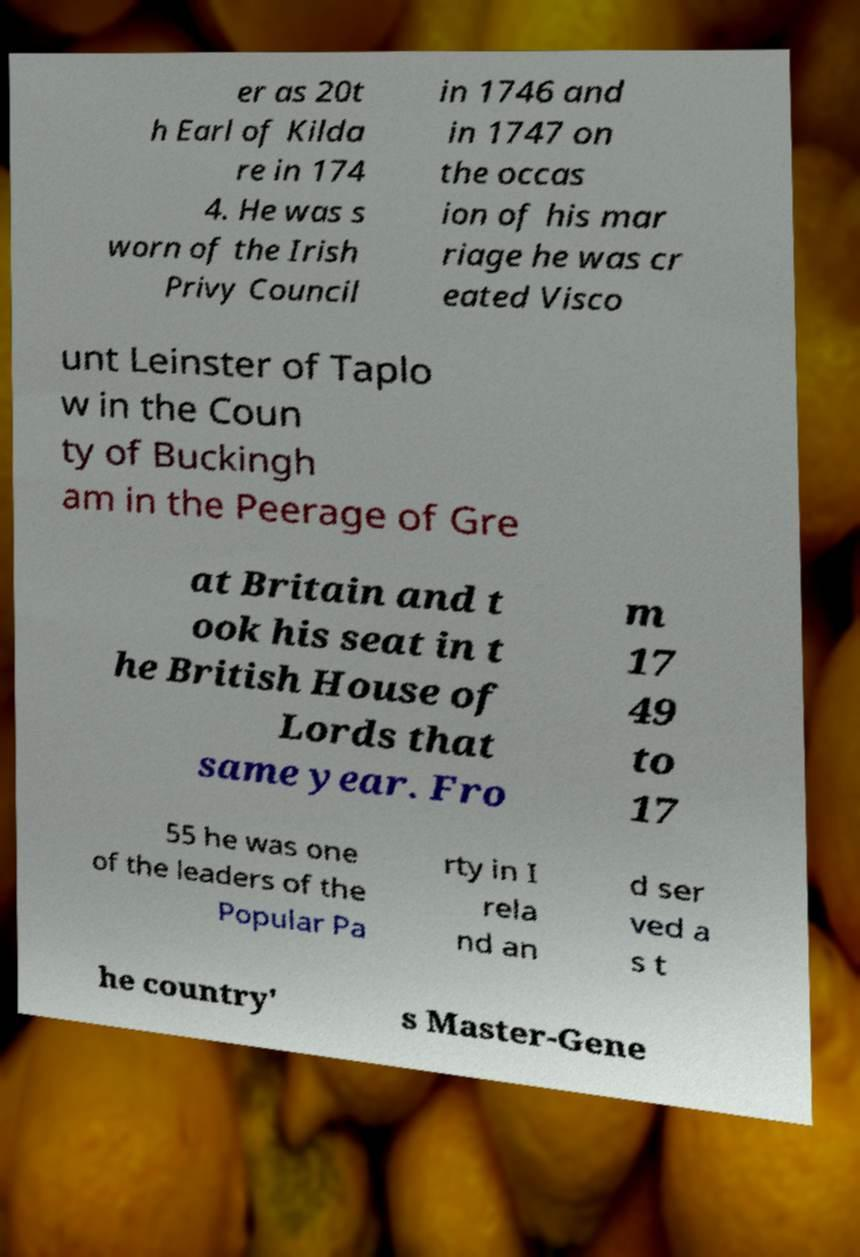Please read and relay the text visible in this image. What does it say? er as 20t h Earl of Kilda re in 174 4. He was s worn of the Irish Privy Council in 1746 and in 1747 on the occas ion of his mar riage he was cr eated Visco unt Leinster of Taplo w in the Coun ty of Buckingh am in the Peerage of Gre at Britain and t ook his seat in t he British House of Lords that same year. Fro m 17 49 to 17 55 he was one of the leaders of the Popular Pa rty in I rela nd an d ser ved a s t he country' s Master-Gene 